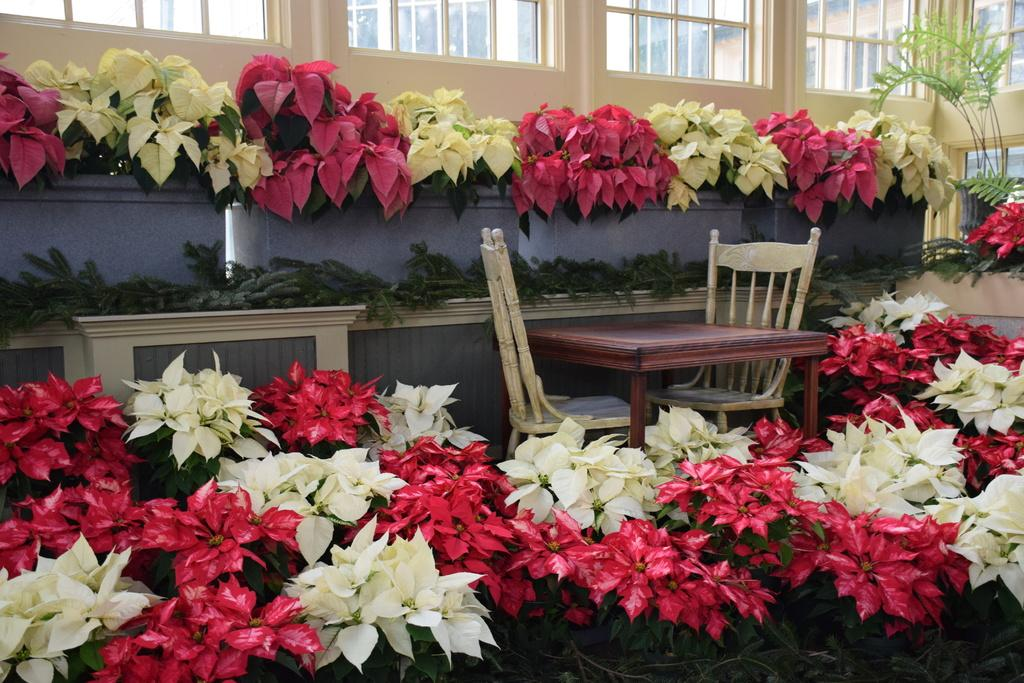What is the main subject of the image? There is a man in the image. What is the man doing in the image? The man is standing and singing. What is the man using while singing? The man is using a microphone. What color is the background behind the man? The background behind the man is yellow. What type of wound can be seen on the man's arm in the image? There is no wound visible on the man's arm in the image. Can you tell me what card game the man is playing in the image? There is no card game or cards present in the image; the man is singing with a microphone. 